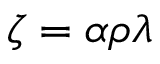<formula> <loc_0><loc_0><loc_500><loc_500>\zeta = \alpha \rho \lambda</formula> 